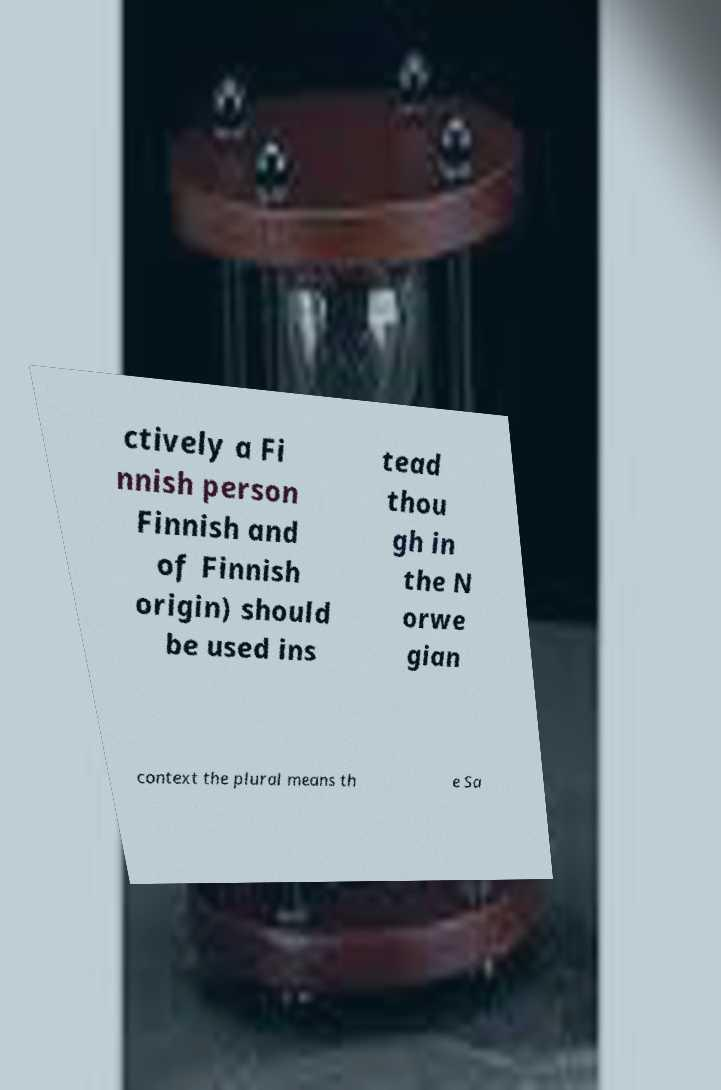Could you assist in decoding the text presented in this image and type it out clearly? ctively a Fi nnish person Finnish and of Finnish origin) should be used ins tead thou gh in the N orwe gian context the plural means th e Sa 